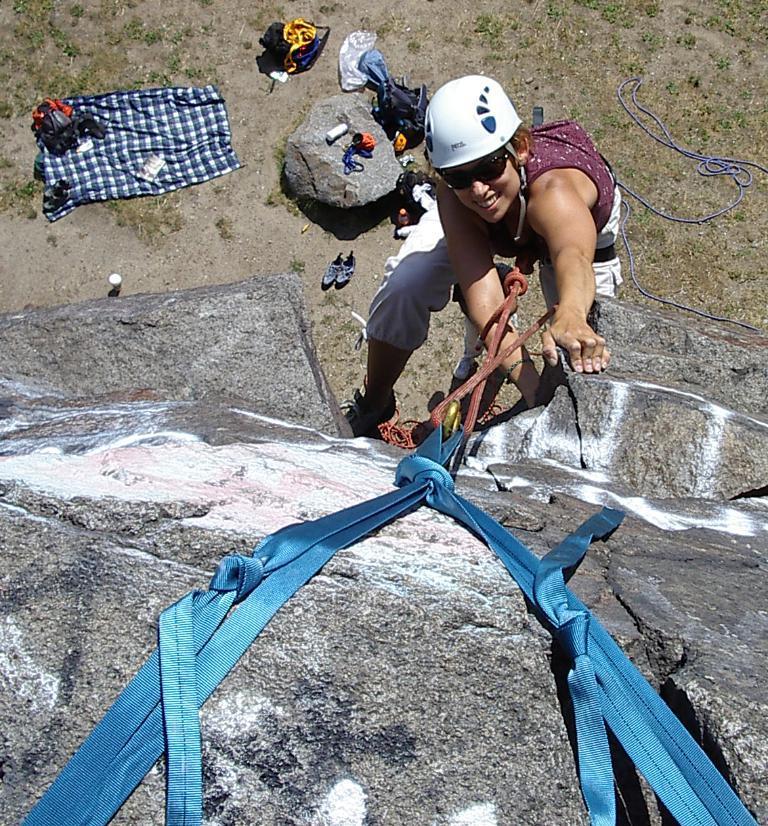Can you describe this image briefly? In the picture we can see a woman climbing the rock with the help of wires and she is with a white color helmet and on the ground we can see a cloth and small rock and near it we can see some things are placed. 